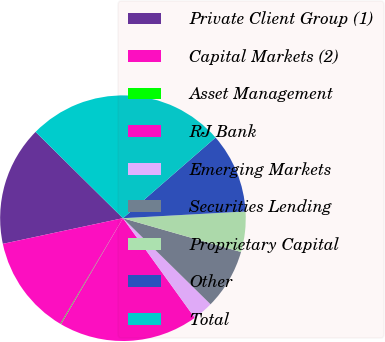<chart> <loc_0><loc_0><loc_500><loc_500><pie_chart><fcel>Private Client Group (1)<fcel>Capital Markets (2)<fcel>Asset Management<fcel>RJ Bank<fcel>Emerging Markets<fcel>Securities Lending<fcel>Proprietary Capital<fcel>Other<fcel>Total<nl><fcel>15.75%<fcel>13.14%<fcel>0.09%<fcel>18.36%<fcel>2.7%<fcel>7.92%<fcel>5.31%<fcel>10.53%<fcel>26.19%<nl></chart> 